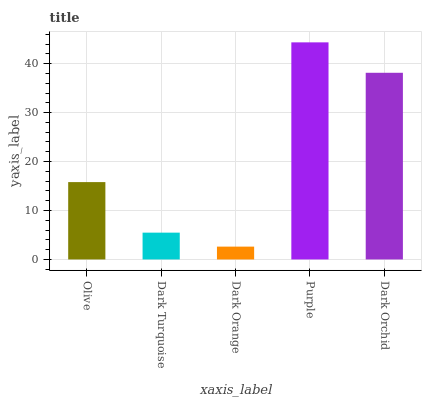Is Dark Orange the minimum?
Answer yes or no. Yes. Is Purple the maximum?
Answer yes or no. Yes. Is Dark Turquoise the minimum?
Answer yes or no. No. Is Dark Turquoise the maximum?
Answer yes or no. No. Is Olive greater than Dark Turquoise?
Answer yes or no. Yes. Is Dark Turquoise less than Olive?
Answer yes or no. Yes. Is Dark Turquoise greater than Olive?
Answer yes or no. No. Is Olive less than Dark Turquoise?
Answer yes or no. No. Is Olive the high median?
Answer yes or no. Yes. Is Olive the low median?
Answer yes or no. Yes. Is Purple the high median?
Answer yes or no. No. Is Dark Orchid the low median?
Answer yes or no. No. 